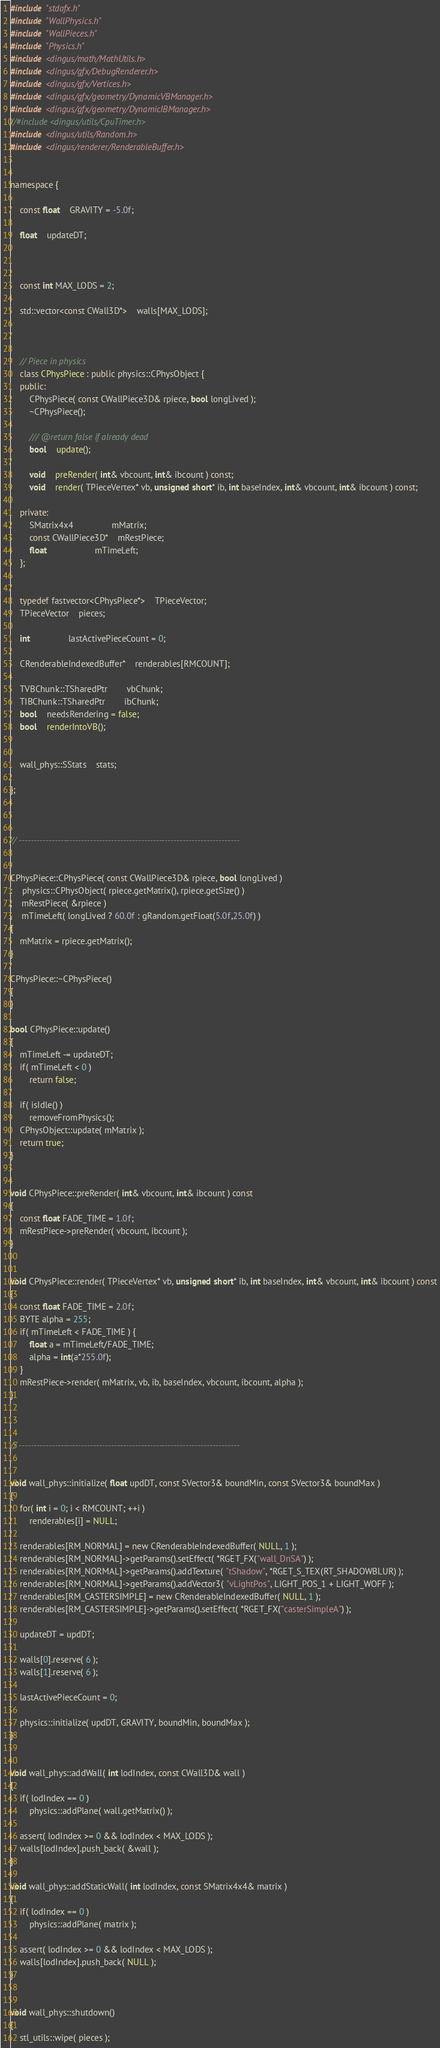Convert code to text. <code><loc_0><loc_0><loc_500><loc_500><_C++_>#include "stdafx.h"
#include "WallPhysics.h"
#include "WallPieces.h"
#include "Physics.h"
#include <dingus/math/MathUtils.h>
#include <dingus/gfx/DebugRenderer.h>
#include <dingus/gfx/Vertices.h>
#include <dingus/gfx/geometry/DynamicVBManager.h>
#include <dingus/gfx/geometry/DynamicIBManager.h>
//#include <dingus/utils/CpuTimer.h>
#include <dingus/utils/Random.h>
#include <dingus/renderer/RenderableBuffer.h>


namespace {

	const float	GRAVITY = -5.0f;

	float	updateDT;



	const int MAX_LODS = 2;

	std::vector<const CWall3D*>	walls[MAX_LODS];



	// Piece in physics
	class CPhysPiece : public physics::CPhysObject {
	public:
		CPhysPiece( const CWallPiece3D& rpiece, bool longLived );
		~CPhysPiece();

		/// @return false if already dead
		bool	update();

		void	preRender( int& vbcount, int& ibcount ) const;
		void	render( TPieceVertex* vb, unsigned short* ib, int baseIndex, int& vbcount, int& ibcount ) const;

	private:
		SMatrix4x4				mMatrix;
		const CWallPiece3D*	mRestPiece;
		float					mTimeLeft;
	};

	
	typedef fastvector<CPhysPiece*>	TPieceVector;
	TPieceVector	pieces;

	int				lastActivePieceCount = 0;

	CRenderableIndexedBuffer*	renderables[RMCOUNT];

	TVBChunk::TSharedPtr		vbChunk;
	TIBChunk::TSharedPtr		ibChunk;
	bool	needsRendering = false;
	bool	renderIntoVB();


	wall_phys::SStats	stats;

};



// --------------------------------------------------------------------------


CPhysPiece::CPhysPiece( const CWallPiece3D& rpiece, bool longLived )
:	physics::CPhysObject( rpiece.getMatrix(), rpiece.getSize() )
,	mRestPiece( &rpiece )
,	mTimeLeft( longLived ? 60.0f : gRandom.getFloat(5.0f,25.0f) )
{
	mMatrix = rpiece.getMatrix();
}

CPhysPiece::~CPhysPiece()
{
}

bool CPhysPiece::update()
{
	mTimeLeft -= updateDT;
	if( mTimeLeft < 0 )
		return false;

	if( isIdle() )
		removeFromPhysics();
	CPhysObject::update( mMatrix );
	return true;
}


void CPhysPiece::preRender( int& vbcount, int& ibcount ) const
{
	const float FADE_TIME = 1.0f;
	mRestPiece->preRender( vbcount, ibcount );
}


void CPhysPiece::render( TPieceVertex* vb, unsigned short* ib, int baseIndex, int& vbcount, int& ibcount ) const
{
	const float FADE_TIME = 2.0f;
	BYTE alpha = 255;
	if( mTimeLeft < FADE_TIME ) {
		float a = mTimeLeft/FADE_TIME;
		alpha = int(a*255.0f);
	}
	mRestPiece->render( mMatrix, vb, ib, baseIndex, vbcount, ibcount, alpha );
}



// --------------------------------------------------------------------------


void wall_phys::initialize( float updDT, const SVector3& boundMin, const SVector3& boundMax )
{
	for( int i = 0; i < RMCOUNT; ++i )
		renderables[i] = NULL;

	renderables[RM_NORMAL] = new CRenderableIndexedBuffer( NULL, 1 );
	renderables[RM_NORMAL]->getParams().setEffect( *RGET_FX("wall_DnSA") );
	renderables[RM_NORMAL]->getParams().addTexture( "tShadow", *RGET_S_TEX(RT_SHADOWBLUR) );
	renderables[RM_NORMAL]->getParams().addVector3( "vLightPos", LIGHT_POS_1 + LIGHT_WOFF );
	renderables[RM_CASTERSIMPLE] = new CRenderableIndexedBuffer( NULL, 1 );
	renderables[RM_CASTERSIMPLE]->getParams().setEffect( *RGET_FX("casterSimpleA") );
	
	updateDT = updDT;

	walls[0].reserve( 6 );
	walls[1].reserve( 6 );

	lastActivePieceCount = 0;

	physics::initialize( updDT, GRAVITY, boundMin, boundMax );
}


void wall_phys::addWall( int lodIndex, const CWall3D& wall )
{
	if( lodIndex == 0 )
		physics::addPlane( wall.getMatrix() );

	assert( lodIndex >= 0 && lodIndex < MAX_LODS );
	walls[lodIndex].push_back( &wall );
}

void wall_phys::addStaticWall( int lodIndex, const SMatrix4x4& matrix )
{
	if( lodIndex == 0 )
		physics::addPlane( matrix );

	assert( lodIndex >= 0 && lodIndex < MAX_LODS );
	walls[lodIndex].push_back( NULL );
}


void wall_phys::shutdown()
{
	stl_utils::wipe( pieces );</code> 